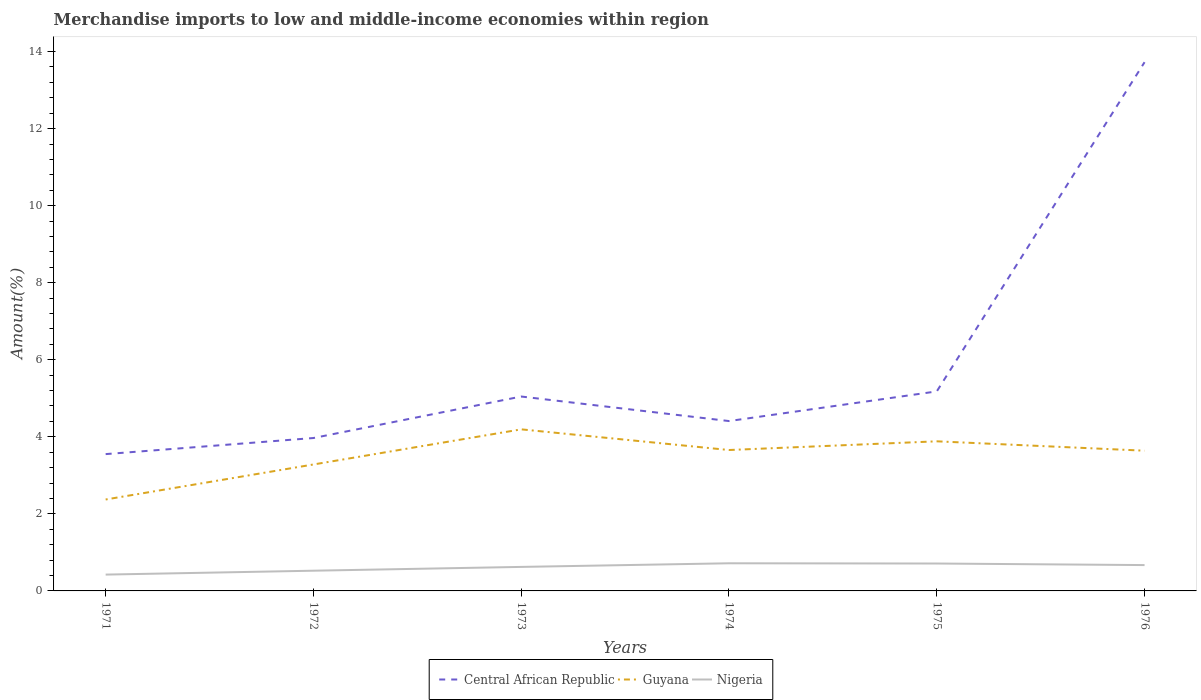How many different coloured lines are there?
Your response must be concise. 3. Does the line corresponding to Nigeria intersect with the line corresponding to Central African Republic?
Your response must be concise. No. Across all years, what is the maximum percentage of amount earned from merchandise imports in Nigeria?
Your response must be concise. 0.42. In which year was the percentage of amount earned from merchandise imports in Guyana maximum?
Keep it short and to the point. 1971. What is the total percentage of amount earned from merchandise imports in Guyana in the graph?
Your response must be concise. -0.38. What is the difference between the highest and the second highest percentage of amount earned from merchandise imports in Central African Republic?
Make the answer very short. 10.17. What is the difference between the highest and the lowest percentage of amount earned from merchandise imports in Nigeria?
Keep it short and to the point. 4. Does the graph contain any zero values?
Your answer should be compact. No. Does the graph contain grids?
Your response must be concise. No. How are the legend labels stacked?
Provide a short and direct response. Horizontal. What is the title of the graph?
Keep it short and to the point. Merchandise imports to low and middle-income economies within region. What is the label or title of the Y-axis?
Your answer should be compact. Amount(%). What is the Amount(%) in Central African Republic in 1971?
Make the answer very short. 3.55. What is the Amount(%) of Guyana in 1971?
Provide a succinct answer. 2.37. What is the Amount(%) of Nigeria in 1971?
Your answer should be very brief. 0.42. What is the Amount(%) in Central African Republic in 1972?
Make the answer very short. 3.97. What is the Amount(%) of Guyana in 1972?
Your answer should be compact. 3.28. What is the Amount(%) of Nigeria in 1972?
Offer a terse response. 0.52. What is the Amount(%) of Central African Republic in 1973?
Keep it short and to the point. 5.05. What is the Amount(%) of Guyana in 1973?
Give a very brief answer. 4.19. What is the Amount(%) in Nigeria in 1973?
Offer a terse response. 0.62. What is the Amount(%) in Central African Republic in 1974?
Offer a terse response. 4.41. What is the Amount(%) of Guyana in 1974?
Make the answer very short. 3.66. What is the Amount(%) of Nigeria in 1974?
Ensure brevity in your answer.  0.72. What is the Amount(%) of Central African Republic in 1975?
Make the answer very short. 5.18. What is the Amount(%) of Guyana in 1975?
Give a very brief answer. 3.88. What is the Amount(%) of Nigeria in 1975?
Keep it short and to the point. 0.71. What is the Amount(%) in Central African Republic in 1976?
Ensure brevity in your answer.  13.72. What is the Amount(%) in Guyana in 1976?
Your answer should be very brief. 3.64. What is the Amount(%) in Nigeria in 1976?
Your response must be concise. 0.67. Across all years, what is the maximum Amount(%) of Central African Republic?
Ensure brevity in your answer.  13.72. Across all years, what is the maximum Amount(%) in Guyana?
Your response must be concise. 4.19. Across all years, what is the maximum Amount(%) in Nigeria?
Your answer should be very brief. 0.72. Across all years, what is the minimum Amount(%) of Central African Republic?
Provide a short and direct response. 3.55. Across all years, what is the minimum Amount(%) in Guyana?
Provide a succinct answer. 2.37. Across all years, what is the minimum Amount(%) of Nigeria?
Provide a short and direct response. 0.42. What is the total Amount(%) in Central African Republic in the graph?
Your response must be concise. 35.88. What is the total Amount(%) of Guyana in the graph?
Your response must be concise. 21.03. What is the total Amount(%) of Nigeria in the graph?
Give a very brief answer. 3.67. What is the difference between the Amount(%) of Central African Republic in 1971 and that in 1972?
Give a very brief answer. -0.42. What is the difference between the Amount(%) of Guyana in 1971 and that in 1972?
Your response must be concise. -0.91. What is the difference between the Amount(%) in Nigeria in 1971 and that in 1972?
Keep it short and to the point. -0.1. What is the difference between the Amount(%) in Central African Republic in 1971 and that in 1973?
Give a very brief answer. -1.49. What is the difference between the Amount(%) in Guyana in 1971 and that in 1973?
Give a very brief answer. -1.82. What is the difference between the Amount(%) in Nigeria in 1971 and that in 1973?
Provide a short and direct response. -0.2. What is the difference between the Amount(%) in Central African Republic in 1971 and that in 1974?
Keep it short and to the point. -0.86. What is the difference between the Amount(%) in Guyana in 1971 and that in 1974?
Keep it short and to the point. -1.28. What is the difference between the Amount(%) in Nigeria in 1971 and that in 1974?
Offer a very short reply. -0.29. What is the difference between the Amount(%) of Central African Republic in 1971 and that in 1975?
Offer a terse response. -1.63. What is the difference between the Amount(%) of Guyana in 1971 and that in 1975?
Make the answer very short. -1.51. What is the difference between the Amount(%) of Nigeria in 1971 and that in 1975?
Make the answer very short. -0.29. What is the difference between the Amount(%) of Central African Republic in 1971 and that in 1976?
Your response must be concise. -10.17. What is the difference between the Amount(%) of Guyana in 1971 and that in 1976?
Keep it short and to the point. -1.27. What is the difference between the Amount(%) of Nigeria in 1971 and that in 1976?
Offer a very short reply. -0.25. What is the difference between the Amount(%) in Central African Republic in 1972 and that in 1973?
Your answer should be very brief. -1.08. What is the difference between the Amount(%) in Guyana in 1972 and that in 1973?
Keep it short and to the point. -0.91. What is the difference between the Amount(%) in Nigeria in 1972 and that in 1973?
Keep it short and to the point. -0.1. What is the difference between the Amount(%) of Central African Republic in 1972 and that in 1974?
Offer a terse response. -0.44. What is the difference between the Amount(%) of Guyana in 1972 and that in 1974?
Provide a succinct answer. -0.38. What is the difference between the Amount(%) of Nigeria in 1972 and that in 1974?
Ensure brevity in your answer.  -0.19. What is the difference between the Amount(%) of Central African Republic in 1972 and that in 1975?
Give a very brief answer. -1.21. What is the difference between the Amount(%) in Guyana in 1972 and that in 1975?
Offer a terse response. -0.6. What is the difference between the Amount(%) of Nigeria in 1972 and that in 1975?
Provide a short and direct response. -0.19. What is the difference between the Amount(%) in Central African Republic in 1972 and that in 1976?
Provide a succinct answer. -9.76. What is the difference between the Amount(%) in Guyana in 1972 and that in 1976?
Your answer should be very brief. -0.36. What is the difference between the Amount(%) of Nigeria in 1972 and that in 1976?
Your answer should be very brief. -0.15. What is the difference between the Amount(%) of Central African Republic in 1973 and that in 1974?
Ensure brevity in your answer.  0.64. What is the difference between the Amount(%) of Guyana in 1973 and that in 1974?
Give a very brief answer. 0.54. What is the difference between the Amount(%) in Nigeria in 1973 and that in 1974?
Your answer should be compact. -0.09. What is the difference between the Amount(%) in Central African Republic in 1973 and that in 1975?
Provide a short and direct response. -0.13. What is the difference between the Amount(%) in Guyana in 1973 and that in 1975?
Your response must be concise. 0.31. What is the difference between the Amount(%) in Nigeria in 1973 and that in 1975?
Offer a very short reply. -0.09. What is the difference between the Amount(%) of Central African Republic in 1973 and that in 1976?
Offer a very short reply. -8.68. What is the difference between the Amount(%) in Guyana in 1973 and that in 1976?
Your response must be concise. 0.55. What is the difference between the Amount(%) of Nigeria in 1973 and that in 1976?
Offer a terse response. -0.05. What is the difference between the Amount(%) of Central African Republic in 1974 and that in 1975?
Provide a short and direct response. -0.77. What is the difference between the Amount(%) of Guyana in 1974 and that in 1975?
Offer a terse response. -0.23. What is the difference between the Amount(%) of Nigeria in 1974 and that in 1975?
Give a very brief answer. 0.01. What is the difference between the Amount(%) of Central African Republic in 1974 and that in 1976?
Offer a terse response. -9.31. What is the difference between the Amount(%) in Guyana in 1974 and that in 1976?
Offer a very short reply. 0.02. What is the difference between the Amount(%) in Nigeria in 1974 and that in 1976?
Your answer should be compact. 0.05. What is the difference between the Amount(%) in Central African Republic in 1975 and that in 1976?
Offer a terse response. -8.54. What is the difference between the Amount(%) in Guyana in 1975 and that in 1976?
Give a very brief answer. 0.24. What is the difference between the Amount(%) in Nigeria in 1975 and that in 1976?
Your response must be concise. 0.04. What is the difference between the Amount(%) of Central African Republic in 1971 and the Amount(%) of Guyana in 1972?
Give a very brief answer. 0.27. What is the difference between the Amount(%) in Central African Republic in 1971 and the Amount(%) in Nigeria in 1972?
Provide a short and direct response. 3.03. What is the difference between the Amount(%) in Guyana in 1971 and the Amount(%) in Nigeria in 1972?
Keep it short and to the point. 1.85. What is the difference between the Amount(%) of Central African Republic in 1971 and the Amount(%) of Guyana in 1973?
Your response must be concise. -0.64. What is the difference between the Amount(%) of Central African Republic in 1971 and the Amount(%) of Nigeria in 1973?
Your answer should be compact. 2.93. What is the difference between the Amount(%) in Guyana in 1971 and the Amount(%) in Nigeria in 1973?
Your response must be concise. 1.75. What is the difference between the Amount(%) in Central African Republic in 1971 and the Amount(%) in Guyana in 1974?
Your answer should be compact. -0.11. What is the difference between the Amount(%) of Central African Republic in 1971 and the Amount(%) of Nigeria in 1974?
Give a very brief answer. 2.83. What is the difference between the Amount(%) of Guyana in 1971 and the Amount(%) of Nigeria in 1974?
Your answer should be compact. 1.66. What is the difference between the Amount(%) in Central African Republic in 1971 and the Amount(%) in Guyana in 1975?
Make the answer very short. -0.33. What is the difference between the Amount(%) of Central African Republic in 1971 and the Amount(%) of Nigeria in 1975?
Make the answer very short. 2.84. What is the difference between the Amount(%) in Guyana in 1971 and the Amount(%) in Nigeria in 1975?
Offer a very short reply. 1.66. What is the difference between the Amount(%) of Central African Republic in 1971 and the Amount(%) of Guyana in 1976?
Make the answer very short. -0.09. What is the difference between the Amount(%) in Central African Republic in 1971 and the Amount(%) in Nigeria in 1976?
Offer a terse response. 2.88. What is the difference between the Amount(%) of Guyana in 1971 and the Amount(%) of Nigeria in 1976?
Offer a very short reply. 1.7. What is the difference between the Amount(%) of Central African Republic in 1972 and the Amount(%) of Guyana in 1973?
Provide a short and direct response. -0.23. What is the difference between the Amount(%) in Central African Republic in 1972 and the Amount(%) in Nigeria in 1973?
Your answer should be compact. 3.35. What is the difference between the Amount(%) in Guyana in 1972 and the Amount(%) in Nigeria in 1973?
Keep it short and to the point. 2.66. What is the difference between the Amount(%) in Central African Republic in 1972 and the Amount(%) in Guyana in 1974?
Give a very brief answer. 0.31. What is the difference between the Amount(%) of Central African Republic in 1972 and the Amount(%) of Nigeria in 1974?
Make the answer very short. 3.25. What is the difference between the Amount(%) of Guyana in 1972 and the Amount(%) of Nigeria in 1974?
Ensure brevity in your answer.  2.56. What is the difference between the Amount(%) in Central African Republic in 1972 and the Amount(%) in Guyana in 1975?
Your answer should be very brief. 0.09. What is the difference between the Amount(%) of Central African Republic in 1972 and the Amount(%) of Nigeria in 1975?
Make the answer very short. 3.26. What is the difference between the Amount(%) in Guyana in 1972 and the Amount(%) in Nigeria in 1975?
Ensure brevity in your answer.  2.57. What is the difference between the Amount(%) in Central African Republic in 1972 and the Amount(%) in Guyana in 1976?
Your response must be concise. 0.33. What is the difference between the Amount(%) in Central African Republic in 1972 and the Amount(%) in Nigeria in 1976?
Provide a succinct answer. 3.3. What is the difference between the Amount(%) of Guyana in 1972 and the Amount(%) of Nigeria in 1976?
Offer a terse response. 2.61. What is the difference between the Amount(%) of Central African Republic in 1973 and the Amount(%) of Guyana in 1974?
Provide a short and direct response. 1.39. What is the difference between the Amount(%) of Central African Republic in 1973 and the Amount(%) of Nigeria in 1974?
Offer a very short reply. 4.33. What is the difference between the Amount(%) of Guyana in 1973 and the Amount(%) of Nigeria in 1974?
Offer a terse response. 3.48. What is the difference between the Amount(%) in Central African Republic in 1973 and the Amount(%) in Guyana in 1975?
Offer a terse response. 1.16. What is the difference between the Amount(%) of Central African Republic in 1973 and the Amount(%) of Nigeria in 1975?
Offer a very short reply. 4.33. What is the difference between the Amount(%) in Guyana in 1973 and the Amount(%) in Nigeria in 1975?
Your answer should be very brief. 3.48. What is the difference between the Amount(%) of Central African Republic in 1973 and the Amount(%) of Guyana in 1976?
Ensure brevity in your answer.  1.41. What is the difference between the Amount(%) of Central African Republic in 1973 and the Amount(%) of Nigeria in 1976?
Provide a short and direct response. 4.37. What is the difference between the Amount(%) of Guyana in 1973 and the Amount(%) of Nigeria in 1976?
Give a very brief answer. 3.52. What is the difference between the Amount(%) in Central African Republic in 1974 and the Amount(%) in Guyana in 1975?
Keep it short and to the point. 0.53. What is the difference between the Amount(%) in Central African Republic in 1974 and the Amount(%) in Nigeria in 1975?
Your answer should be very brief. 3.7. What is the difference between the Amount(%) of Guyana in 1974 and the Amount(%) of Nigeria in 1975?
Provide a short and direct response. 2.95. What is the difference between the Amount(%) of Central African Republic in 1974 and the Amount(%) of Guyana in 1976?
Provide a succinct answer. 0.77. What is the difference between the Amount(%) of Central African Republic in 1974 and the Amount(%) of Nigeria in 1976?
Your response must be concise. 3.74. What is the difference between the Amount(%) of Guyana in 1974 and the Amount(%) of Nigeria in 1976?
Ensure brevity in your answer.  2.99. What is the difference between the Amount(%) in Central African Republic in 1975 and the Amount(%) in Guyana in 1976?
Make the answer very short. 1.54. What is the difference between the Amount(%) in Central African Republic in 1975 and the Amount(%) in Nigeria in 1976?
Ensure brevity in your answer.  4.51. What is the difference between the Amount(%) in Guyana in 1975 and the Amount(%) in Nigeria in 1976?
Provide a succinct answer. 3.21. What is the average Amount(%) of Central African Republic per year?
Make the answer very short. 5.98. What is the average Amount(%) of Guyana per year?
Offer a very short reply. 3.5. What is the average Amount(%) of Nigeria per year?
Keep it short and to the point. 0.61. In the year 1971, what is the difference between the Amount(%) of Central African Republic and Amount(%) of Guyana?
Make the answer very short. 1.18. In the year 1971, what is the difference between the Amount(%) of Central African Republic and Amount(%) of Nigeria?
Your answer should be very brief. 3.13. In the year 1971, what is the difference between the Amount(%) of Guyana and Amount(%) of Nigeria?
Ensure brevity in your answer.  1.95. In the year 1972, what is the difference between the Amount(%) in Central African Republic and Amount(%) in Guyana?
Give a very brief answer. 0.69. In the year 1972, what is the difference between the Amount(%) in Central African Republic and Amount(%) in Nigeria?
Make the answer very short. 3.44. In the year 1972, what is the difference between the Amount(%) of Guyana and Amount(%) of Nigeria?
Your answer should be compact. 2.76. In the year 1973, what is the difference between the Amount(%) of Central African Republic and Amount(%) of Guyana?
Give a very brief answer. 0.85. In the year 1973, what is the difference between the Amount(%) in Central African Republic and Amount(%) in Nigeria?
Give a very brief answer. 4.42. In the year 1973, what is the difference between the Amount(%) of Guyana and Amount(%) of Nigeria?
Give a very brief answer. 3.57. In the year 1974, what is the difference between the Amount(%) of Central African Republic and Amount(%) of Guyana?
Offer a very short reply. 0.75. In the year 1974, what is the difference between the Amount(%) of Central African Republic and Amount(%) of Nigeria?
Your response must be concise. 3.69. In the year 1974, what is the difference between the Amount(%) of Guyana and Amount(%) of Nigeria?
Make the answer very short. 2.94. In the year 1975, what is the difference between the Amount(%) of Central African Republic and Amount(%) of Guyana?
Offer a very short reply. 1.3. In the year 1975, what is the difference between the Amount(%) in Central African Republic and Amount(%) in Nigeria?
Provide a succinct answer. 4.47. In the year 1975, what is the difference between the Amount(%) of Guyana and Amount(%) of Nigeria?
Your answer should be very brief. 3.17. In the year 1976, what is the difference between the Amount(%) of Central African Republic and Amount(%) of Guyana?
Provide a succinct answer. 10.08. In the year 1976, what is the difference between the Amount(%) in Central African Republic and Amount(%) in Nigeria?
Your answer should be compact. 13.05. In the year 1976, what is the difference between the Amount(%) in Guyana and Amount(%) in Nigeria?
Offer a very short reply. 2.97. What is the ratio of the Amount(%) of Central African Republic in 1971 to that in 1972?
Your answer should be very brief. 0.89. What is the ratio of the Amount(%) in Guyana in 1971 to that in 1972?
Your answer should be compact. 0.72. What is the ratio of the Amount(%) of Nigeria in 1971 to that in 1972?
Your response must be concise. 0.81. What is the ratio of the Amount(%) of Central African Republic in 1971 to that in 1973?
Provide a succinct answer. 0.7. What is the ratio of the Amount(%) in Guyana in 1971 to that in 1973?
Provide a succinct answer. 0.57. What is the ratio of the Amount(%) in Nigeria in 1971 to that in 1973?
Ensure brevity in your answer.  0.68. What is the ratio of the Amount(%) of Central African Republic in 1971 to that in 1974?
Provide a short and direct response. 0.81. What is the ratio of the Amount(%) in Guyana in 1971 to that in 1974?
Provide a short and direct response. 0.65. What is the ratio of the Amount(%) in Nigeria in 1971 to that in 1974?
Offer a very short reply. 0.59. What is the ratio of the Amount(%) of Central African Republic in 1971 to that in 1975?
Your response must be concise. 0.69. What is the ratio of the Amount(%) in Guyana in 1971 to that in 1975?
Keep it short and to the point. 0.61. What is the ratio of the Amount(%) of Nigeria in 1971 to that in 1975?
Make the answer very short. 0.6. What is the ratio of the Amount(%) of Central African Republic in 1971 to that in 1976?
Your answer should be very brief. 0.26. What is the ratio of the Amount(%) in Guyana in 1971 to that in 1976?
Provide a short and direct response. 0.65. What is the ratio of the Amount(%) of Nigeria in 1971 to that in 1976?
Give a very brief answer. 0.63. What is the ratio of the Amount(%) in Central African Republic in 1972 to that in 1973?
Ensure brevity in your answer.  0.79. What is the ratio of the Amount(%) of Guyana in 1972 to that in 1973?
Offer a terse response. 0.78. What is the ratio of the Amount(%) in Nigeria in 1972 to that in 1973?
Your answer should be compact. 0.84. What is the ratio of the Amount(%) of Central African Republic in 1972 to that in 1974?
Offer a very short reply. 0.9. What is the ratio of the Amount(%) of Guyana in 1972 to that in 1974?
Your response must be concise. 0.9. What is the ratio of the Amount(%) of Nigeria in 1972 to that in 1974?
Keep it short and to the point. 0.73. What is the ratio of the Amount(%) of Central African Republic in 1972 to that in 1975?
Provide a succinct answer. 0.77. What is the ratio of the Amount(%) of Guyana in 1972 to that in 1975?
Make the answer very short. 0.85. What is the ratio of the Amount(%) in Nigeria in 1972 to that in 1975?
Give a very brief answer. 0.74. What is the ratio of the Amount(%) in Central African Republic in 1972 to that in 1976?
Provide a succinct answer. 0.29. What is the ratio of the Amount(%) of Guyana in 1972 to that in 1976?
Your response must be concise. 0.9. What is the ratio of the Amount(%) in Nigeria in 1972 to that in 1976?
Offer a terse response. 0.78. What is the ratio of the Amount(%) of Central African Republic in 1973 to that in 1974?
Offer a very short reply. 1.14. What is the ratio of the Amount(%) of Guyana in 1973 to that in 1974?
Your response must be concise. 1.15. What is the ratio of the Amount(%) in Nigeria in 1973 to that in 1974?
Your response must be concise. 0.87. What is the ratio of the Amount(%) of Central African Republic in 1973 to that in 1975?
Your answer should be very brief. 0.97. What is the ratio of the Amount(%) in Nigeria in 1973 to that in 1975?
Give a very brief answer. 0.88. What is the ratio of the Amount(%) in Central African Republic in 1973 to that in 1976?
Your response must be concise. 0.37. What is the ratio of the Amount(%) of Guyana in 1973 to that in 1976?
Offer a terse response. 1.15. What is the ratio of the Amount(%) in Nigeria in 1973 to that in 1976?
Offer a terse response. 0.93. What is the ratio of the Amount(%) in Central African Republic in 1974 to that in 1975?
Your response must be concise. 0.85. What is the ratio of the Amount(%) of Guyana in 1974 to that in 1975?
Offer a very short reply. 0.94. What is the ratio of the Amount(%) in Nigeria in 1974 to that in 1975?
Keep it short and to the point. 1.01. What is the ratio of the Amount(%) in Central African Republic in 1974 to that in 1976?
Give a very brief answer. 0.32. What is the ratio of the Amount(%) of Guyana in 1974 to that in 1976?
Make the answer very short. 1. What is the ratio of the Amount(%) in Nigeria in 1974 to that in 1976?
Your response must be concise. 1.07. What is the ratio of the Amount(%) of Central African Republic in 1975 to that in 1976?
Offer a terse response. 0.38. What is the ratio of the Amount(%) of Guyana in 1975 to that in 1976?
Offer a very short reply. 1.07. What is the ratio of the Amount(%) of Nigeria in 1975 to that in 1976?
Your answer should be compact. 1.06. What is the difference between the highest and the second highest Amount(%) of Central African Republic?
Your answer should be compact. 8.54. What is the difference between the highest and the second highest Amount(%) in Guyana?
Your answer should be compact. 0.31. What is the difference between the highest and the second highest Amount(%) in Nigeria?
Ensure brevity in your answer.  0.01. What is the difference between the highest and the lowest Amount(%) of Central African Republic?
Your answer should be very brief. 10.17. What is the difference between the highest and the lowest Amount(%) of Guyana?
Provide a short and direct response. 1.82. What is the difference between the highest and the lowest Amount(%) of Nigeria?
Keep it short and to the point. 0.29. 